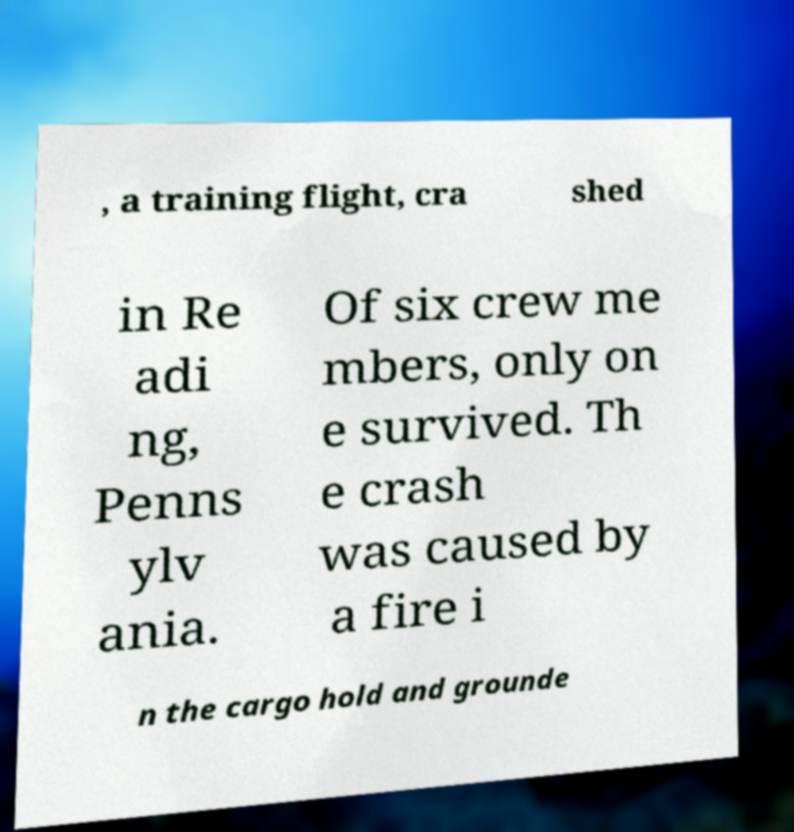Can you read and provide the text displayed in the image?This photo seems to have some interesting text. Can you extract and type it out for me? , a training flight, cra shed in Re adi ng, Penns ylv ania. Of six crew me mbers, only on e survived. Th e crash was caused by a fire i n the cargo hold and grounde 